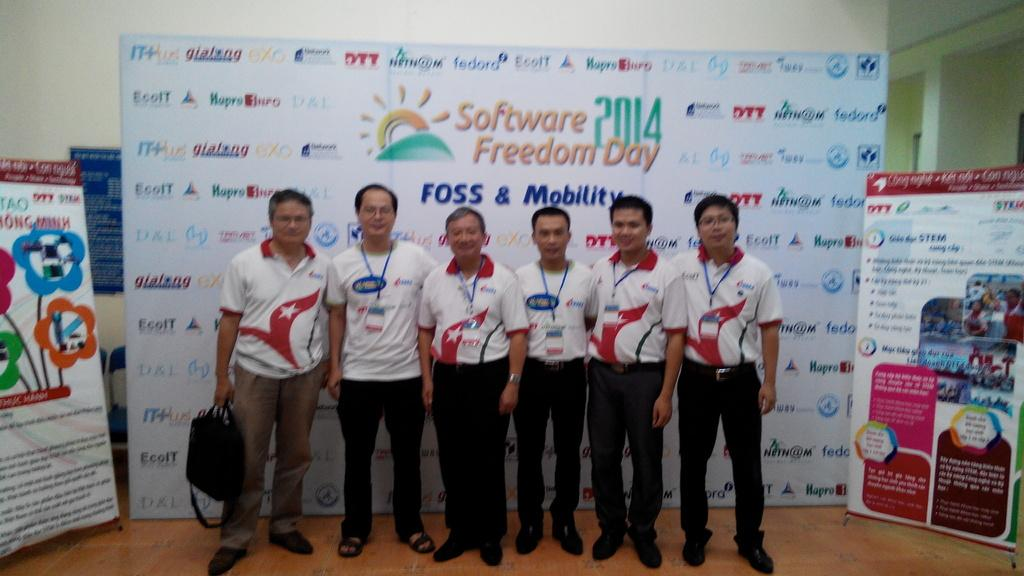<image>
Summarize the visual content of the image. Group of men taking a picture in front of a board that says "Software Freedom Day". 